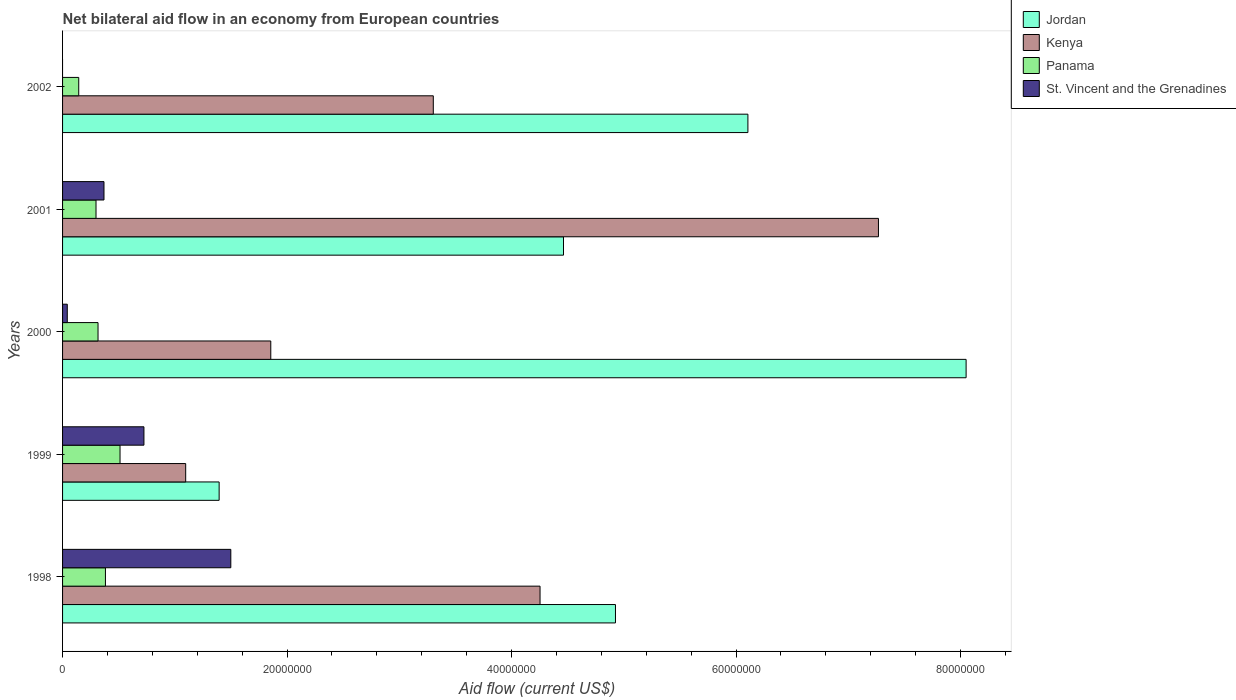How many groups of bars are there?
Provide a short and direct response. 5. How many bars are there on the 2nd tick from the top?
Your response must be concise. 4. How many bars are there on the 3rd tick from the bottom?
Offer a terse response. 4. What is the label of the 4th group of bars from the top?
Provide a short and direct response. 1999. What is the net bilateral aid flow in Jordan in 1999?
Provide a short and direct response. 1.40e+07. Across all years, what is the maximum net bilateral aid flow in St. Vincent and the Grenadines?
Your answer should be very brief. 1.50e+07. Across all years, what is the minimum net bilateral aid flow in St. Vincent and the Grenadines?
Make the answer very short. 0. In which year was the net bilateral aid flow in St. Vincent and the Grenadines maximum?
Make the answer very short. 1998. What is the total net bilateral aid flow in St. Vincent and the Grenadines in the graph?
Provide a succinct answer. 2.64e+07. What is the difference between the net bilateral aid flow in Kenya in 1998 and that in 2001?
Keep it short and to the point. -3.02e+07. What is the difference between the net bilateral aid flow in Panama in 1998 and the net bilateral aid flow in Jordan in 2001?
Offer a very short reply. -4.08e+07. What is the average net bilateral aid flow in Panama per year?
Your response must be concise. 3.30e+06. In the year 2002, what is the difference between the net bilateral aid flow in Jordan and net bilateral aid flow in Panama?
Your answer should be very brief. 5.96e+07. In how many years, is the net bilateral aid flow in Panama greater than 72000000 US$?
Keep it short and to the point. 0. What is the ratio of the net bilateral aid flow in Panama in 2000 to that in 2001?
Provide a short and direct response. 1.06. What is the difference between the highest and the second highest net bilateral aid flow in Jordan?
Your answer should be compact. 1.94e+07. What is the difference between the highest and the lowest net bilateral aid flow in Panama?
Ensure brevity in your answer.  3.68e+06. Are all the bars in the graph horizontal?
Keep it short and to the point. Yes. How many years are there in the graph?
Offer a terse response. 5. Are the values on the major ticks of X-axis written in scientific E-notation?
Provide a short and direct response. No. Does the graph contain any zero values?
Offer a terse response. Yes. Does the graph contain grids?
Keep it short and to the point. No. What is the title of the graph?
Provide a succinct answer. Net bilateral aid flow in an economy from European countries. Does "Mexico" appear as one of the legend labels in the graph?
Provide a succinct answer. No. What is the label or title of the Y-axis?
Provide a short and direct response. Years. What is the Aid flow (current US$) in Jordan in 1998?
Offer a very short reply. 4.93e+07. What is the Aid flow (current US$) of Kenya in 1998?
Offer a terse response. 4.25e+07. What is the Aid flow (current US$) of Panama in 1998?
Make the answer very short. 3.82e+06. What is the Aid flow (current US$) in St. Vincent and the Grenadines in 1998?
Your answer should be compact. 1.50e+07. What is the Aid flow (current US$) of Jordan in 1999?
Give a very brief answer. 1.40e+07. What is the Aid flow (current US$) of Kenya in 1999?
Offer a very short reply. 1.10e+07. What is the Aid flow (current US$) of Panama in 1999?
Your response must be concise. 5.12e+06. What is the Aid flow (current US$) of St. Vincent and the Grenadines in 1999?
Ensure brevity in your answer.  7.25e+06. What is the Aid flow (current US$) of Jordan in 2000?
Ensure brevity in your answer.  8.05e+07. What is the Aid flow (current US$) of Kenya in 2000?
Offer a very short reply. 1.86e+07. What is the Aid flow (current US$) in Panama in 2000?
Give a very brief answer. 3.16e+06. What is the Aid flow (current US$) in St. Vincent and the Grenadines in 2000?
Offer a very short reply. 4.20e+05. What is the Aid flow (current US$) in Jordan in 2001?
Make the answer very short. 4.46e+07. What is the Aid flow (current US$) of Kenya in 2001?
Your answer should be compact. 7.27e+07. What is the Aid flow (current US$) of Panama in 2001?
Your response must be concise. 2.98e+06. What is the Aid flow (current US$) in St. Vincent and the Grenadines in 2001?
Ensure brevity in your answer.  3.69e+06. What is the Aid flow (current US$) of Jordan in 2002?
Provide a short and direct response. 6.11e+07. What is the Aid flow (current US$) of Kenya in 2002?
Your response must be concise. 3.30e+07. What is the Aid flow (current US$) of Panama in 2002?
Your answer should be very brief. 1.44e+06. Across all years, what is the maximum Aid flow (current US$) in Jordan?
Your answer should be compact. 8.05e+07. Across all years, what is the maximum Aid flow (current US$) of Kenya?
Your answer should be compact. 7.27e+07. Across all years, what is the maximum Aid flow (current US$) in Panama?
Make the answer very short. 5.12e+06. Across all years, what is the maximum Aid flow (current US$) of St. Vincent and the Grenadines?
Your answer should be compact. 1.50e+07. Across all years, what is the minimum Aid flow (current US$) of Jordan?
Offer a terse response. 1.40e+07. Across all years, what is the minimum Aid flow (current US$) of Kenya?
Provide a short and direct response. 1.10e+07. Across all years, what is the minimum Aid flow (current US$) of Panama?
Provide a succinct answer. 1.44e+06. What is the total Aid flow (current US$) of Jordan in the graph?
Provide a succinct answer. 2.49e+08. What is the total Aid flow (current US$) in Kenya in the graph?
Give a very brief answer. 1.78e+08. What is the total Aid flow (current US$) of Panama in the graph?
Offer a terse response. 1.65e+07. What is the total Aid flow (current US$) of St. Vincent and the Grenadines in the graph?
Offer a terse response. 2.64e+07. What is the difference between the Aid flow (current US$) in Jordan in 1998 and that in 1999?
Keep it short and to the point. 3.53e+07. What is the difference between the Aid flow (current US$) in Kenya in 1998 and that in 1999?
Your answer should be very brief. 3.16e+07. What is the difference between the Aid flow (current US$) of Panama in 1998 and that in 1999?
Offer a very short reply. -1.30e+06. What is the difference between the Aid flow (current US$) in St. Vincent and the Grenadines in 1998 and that in 1999?
Provide a succinct answer. 7.74e+06. What is the difference between the Aid flow (current US$) in Jordan in 1998 and that in 2000?
Keep it short and to the point. -3.12e+07. What is the difference between the Aid flow (current US$) of Kenya in 1998 and that in 2000?
Ensure brevity in your answer.  2.40e+07. What is the difference between the Aid flow (current US$) in Panama in 1998 and that in 2000?
Make the answer very short. 6.60e+05. What is the difference between the Aid flow (current US$) in St. Vincent and the Grenadines in 1998 and that in 2000?
Offer a very short reply. 1.46e+07. What is the difference between the Aid flow (current US$) in Jordan in 1998 and that in 2001?
Offer a very short reply. 4.63e+06. What is the difference between the Aid flow (current US$) in Kenya in 1998 and that in 2001?
Make the answer very short. -3.02e+07. What is the difference between the Aid flow (current US$) in Panama in 1998 and that in 2001?
Ensure brevity in your answer.  8.40e+05. What is the difference between the Aid flow (current US$) in St. Vincent and the Grenadines in 1998 and that in 2001?
Your response must be concise. 1.13e+07. What is the difference between the Aid flow (current US$) of Jordan in 1998 and that in 2002?
Give a very brief answer. -1.18e+07. What is the difference between the Aid flow (current US$) of Kenya in 1998 and that in 2002?
Ensure brevity in your answer.  9.51e+06. What is the difference between the Aid flow (current US$) in Panama in 1998 and that in 2002?
Your answer should be very brief. 2.38e+06. What is the difference between the Aid flow (current US$) in Jordan in 1999 and that in 2000?
Your answer should be compact. -6.66e+07. What is the difference between the Aid flow (current US$) in Kenya in 1999 and that in 2000?
Provide a short and direct response. -7.58e+06. What is the difference between the Aid flow (current US$) in Panama in 1999 and that in 2000?
Keep it short and to the point. 1.96e+06. What is the difference between the Aid flow (current US$) in St. Vincent and the Grenadines in 1999 and that in 2000?
Your answer should be very brief. 6.83e+06. What is the difference between the Aid flow (current US$) in Jordan in 1999 and that in 2001?
Your answer should be very brief. -3.07e+07. What is the difference between the Aid flow (current US$) of Kenya in 1999 and that in 2001?
Your answer should be compact. -6.17e+07. What is the difference between the Aid flow (current US$) in Panama in 1999 and that in 2001?
Offer a terse response. 2.14e+06. What is the difference between the Aid flow (current US$) in St. Vincent and the Grenadines in 1999 and that in 2001?
Provide a succinct answer. 3.56e+06. What is the difference between the Aid flow (current US$) of Jordan in 1999 and that in 2002?
Offer a very short reply. -4.71e+07. What is the difference between the Aid flow (current US$) of Kenya in 1999 and that in 2002?
Offer a terse response. -2.21e+07. What is the difference between the Aid flow (current US$) of Panama in 1999 and that in 2002?
Your answer should be very brief. 3.68e+06. What is the difference between the Aid flow (current US$) in Jordan in 2000 and that in 2001?
Keep it short and to the point. 3.59e+07. What is the difference between the Aid flow (current US$) of Kenya in 2000 and that in 2001?
Your answer should be very brief. -5.41e+07. What is the difference between the Aid flow (current US$) of Panama in 2000 and that in 2001?
Provide a short and direct response. 1.80e+05. What is the difference between the Aid flow (current US$) in St. Vincent and the Grenadines in 2000 and that in 2001?
Ensure brevity in your answer.  -3.27e+06. What is the difference between the Aid flow (current US$) in Jordan in 2000 and that in 2002?
Offer a terse response. 1.94e+07. What is the difference between the Aid flow (current US$) in Kenya in 2000 and that in 2002?
Keep it short and to the point. -1.45e+07. What is the difference between the Aid flow (current US$) of Panama in 2000 and that in 2002?
Keep it short and to the point. 1.72e+06. What is the difference between the Aid flow (current US$) in Jordan in 2001 and that in 2002?
Your answer should be compact. -1.64e+07. What is the difference between the Aid flow (current US$) in Kenya in 2001 and that in 2002?
Ensure brevity in your answer.  3.97e+07. What is the difference between the Aid flow (current US$) of Panama in 2001 and that in 2002?
Make the answer very short. 1.54e+06. What is the difference between the Aid flow (current US$) in Jordan in 1998 and the Aid flow (current US$) in Kenya in 1999?
Provide a short and direct response. 3.83e+07. What is the difference between the Aid flow (current US$) in Jordan in 1998 and the Aid flow (current US$) in Panama in 1999?
Make the answer very short. 4.41e+07. What is the difference between the Aid flow (current US$) in Jordan in 1998 and the Aid flow (current US$) in St. Vincent and the Grenadines in 1999?
Offer a terse response. 4.20e+07. What is the difference between the Aid flow (current US$) of Kenya in 1998 and the Aid flow (current US$) of Panama in 1999?
Offer a very short reply. 3.74e+07. What is the difference between the Aid flow (current US$) in Kenya in 1998 and the Aid flow (current US$) in St. Vincent and the Grenadines in 1999?
Ensure brevity in your answer.  3.53e+07. What is the difference between the Aid flow (current US$) of Panama in 1998 and the Aid flow (current US$) of St. Vincent and the Grenadines in 1999?
Provide a short and direct response. -3.43e+06. What is the difference between the Aid flow (current US$) in Jordan in 1998 and the Aid flow (current US$) in Kenya in 2000?
Provide a succinct answer. 3.07e+07. What is the difference between the Aid flow (current US$) of Jordan in 1998 and the Aid flow (current US$) of Panama in 2000?
Keep it short and to the point. 4.61e+07. What is the difference between the Aid flow (current US$) in Jordan in 1998 and the Aid flow (current US$) in St. Vincent and the Grenadines in 2000?
Your answer should be compact. 4.88e+07. What is the difference between the Aid flow (current US$) in Kenya in 1998 and the Aid flow (current US$) in Panama in 2000?
Your answer should be compact. 3.94e+07. What is the difference between the Aid flow (current US$) of Kenya in 1998 and the Aid flow (current US$) of St. Vincent and the Grenadines in 2000?
Your answer should be very brief. 4.21e+07. What is the difference between the Aid flow (current US$) of Panama in 1998 and the Aid flow (current US$) of St. Vincent and the Grenadines in 2000?
Offer a very short reply. 3.40e+06. What is the difference between the Aid flow (current US$) of Jordan in 1998 and the Aid flow (current US$) of Kenya in 2001?
Keep it short and to the point. -2.34e+07. What is the difference between the Aid flow (current US$) in Jordan in 1998 and the Aid flow (current US$) in Panama in 2001?
Your answer should be compact. 4.63e+07. What is the difference between the Aid flow (current US$) of Jordan in 1998 and the Aid flow (current US$) of St. Vincent and the Grenadines in 2001?
Give a very brief answer. 4.56e+07. What is the difference between the Aid flow (current US$) in Kenya in 1998 and the Aid flow (current US$) in Panama in 2001?
Give a very brief answer. 3.96e+07. What is the difference between the Aid flow (current US$) in Kenya in 1998 and the Aid flow (current US$) in St. Vincent and the Grenadines in 2001?
Keep it short and to the point. 3.88e+07. What is the difference between the Aid flow (current US$) in Panama in 1998 and the Aid flow (current US$) in St. Vincent and the Grenadines in 2001?
Provide a succinct answer. 1.30e+05. What is the difference between the Aid flow (current US$) in Jordan in 1998 and the Aid flow (current US$) in Kenya in 2002?
Your response must be concise. 1.62e+07. What is the difference between the Aid flow (current US$) in Jordan in 1998 and the Aid flow (current US$) in Panama in 2002?
Your answer should be compact. 4.78e+07. What is the difference between the Aid flow (current US$) of Kenya in 1998 and the Aid flow (current US$) of Panama in 2002?
Make the answer very short. 4.11e+07. What is the difference between the Aid flow (current US$) in Jordan in 1999 and the Aid flow (current US$) in Kenya in 2000?
Keep it short and to the point. -4.60e+06. What is the difference between the Aid flow (current US$) in Jordan in 1999 and the Aid flow (current US$) in Panama in 2000?
Ensure brevity in your answer.  1.08e+07. What is the difference between the Aid flow (current US$) in Jordan in 1999 and the Aid flow (current US$) in St. Vincent and the Grenadines in 2000?
Provide a short and direct response. 1.35e+07. What is the difference between the Aid flow (current US$) of Kenya in 1999 and the Aid flow (current US$) of Panama in 2000?
Make the answer very short. 7.81e+06. What is the difference between the Aid flow (current US$) in Kenya in 1999 and the Aid flow (current US$) in St. Vincent and the Grenadines in 2000?
Your response must be concise. 1.06e+07. What is the difference between the Aid flow (current US$) in Panama in 1999 and the Aid flow (current US$) in St. Vincent and the Grenadines in 2000?
Offer a terse response. 4.70e+06. What is the difference between the Aid flow (current US$) in Jordan in 1999 and the Aid flow (current US$) in Kenya in 2001?
Provide a succinct answer. -5.87e+07. What is the difference between the Aid flow (current US$) of Jordan in 1999 and the Aid flow (current US$) of Panama in 2001?
Give a very brief answer. 1.10e+07. What is the difference between the Aid flow (current US$) of Jordan in 1999 and the Aid flow (current US$) of St. Vincent and the Grenadines in 2001?
Ensure brevity in your answer.  1.03e+07. What is the difference between the Aid flow (current US$) of Kenya in 1999 and the Aid flow (current US$) of Panama in 2001?
Keep it short and to the point. 7.99e+06. What is the difference between the Aid flow (current US$) in Kenya in 1999 and the Aid flow (current US$) in St. Vincent and the Grenadines in 2001?
Provide a short and direct response. 7.28e+06. What is the difference between the Aid flow (current US$) in Panama in 1999 and the Aid flow (current US$) in St. Vincent and the Grenadines in 2001?
Provide a short and direct response. 1.43e+06. What is the difference between the Aid flow (current US$) of Jordan in 1999 and the Aid flow (current US$) of Kenya in 2002?
Offer a terse response. -1.91e+07. What is the difference between the Aid flow (current US$) of Jordan in 1999 and the Aid flow (current US$) of Panama in 2002?
Provide a short and direct response. 1.25e+07. What is the difference between the Aid flow (current US$) in Kenya in 1999 and the Aid flow (current US$) in Panama in 2002?
Offer a terse response. 9.53e+06. What is the difference between the Aid flow (current US$) in Jordan in 2000 and the Aid flow (current US$) in Kenya in 2001?
Provide a short and direct response. 7.81e+06. What is the difference between the Aid flow (current US$) of Jordan in 2000 and the Aid flow (current US$) of Panama in 2001?
Ensure brevity in your answer.  7.75e+07. What is the difference between the Aid flow (current US$) in Jordan in 2000 and the Aid flow (current US$) in St. Vincent and the Grenadines in 2001?
Your answer should be compact. 7.68e+07. What is the difference between the Aid flow (current US$) of Kenya in 2000 and the Aid flow (current US$) of Panama in 2001?
Your response must be concise. 1.56e+07. What is the difference between the Aid flow (current US$) in Kenya in 2000 and the Aid flow (current US$) in St. Vincent and the Grenadines in 2001?
Provide a short and direct response. 1.49e+07. What is the difference between the Aid flow (current US$) of Panama in 2000 and the Aid flow (current US$) of St. Vincent and the Grenadines in 2001?
Your answer should be compact. -5.30e+05. What is the difference between the Aid flow (current US$) of Jordan in 2000 and the Aid flow (current US$) of Kenya in 2002?
Offer a terse response. 4.75e+07. What is the difference between the Aid flow (current US$) of Jordan in 2000 and the Aid flow (current US$) of Panama in 2002?
Offer a very short reply. 7.91e+07. What is the difference between the Aid flow (current US$) of Kenya in 2000 and the Aid flow (current US$) of Panama in 2002?
Offer a very short reply. 1.71e+07. What is the difference between the Aid flow (current US$) in Jordan in 2001 and the Aid flow (current US$) in Kenya in 2002?
Make the answer very short. 1.16e+07. What is the difference between the Aid flow (current US$) of Jordan in 2001 and the Aid flow (current US$) of Panama in 2002?
Offer a terse response. 4.32e+07. What is the difference between the Aid flow (current US$) of Kenya in 2001 and the Aid flow (current US$) of Panama in 2002?
Give a very brief answer. 7.12e+07. What is the average Aid flow (current US$) in Jordan per year?
Ensure brevity in your answer.  4.99e+07. What is the average Aid flow (current US$) in Kenya per year?
Offer a terse response. 3.56e+07. What is the average Aid flow (current US$) in Panama per year?
Your answer should be very brief. 3.30e+06. What is the average Aid flow (current US$) of St. Vincent and the Grenadines per year?
Ensure brevity in your answer.  5.27e+06. In the year 1998, what is the difference between the Aid flow (current US$) of Jordan and Aid flow (current US$) of Kenya?
Provide a short and direct response. 6.72e+06. In the year 1998, what is the difference between the Aid flow (current US$) of Jordan and Aid flow (current US$) of Panama?
Your response must be concise. 4.54e+07. In the year 1998, what is the difference between the Aid flow (current US$) of Jordan and Aid flow (current US$) of St. Vincent and the Grenadines?
Give a very brief answer. 3.43e+07. In the year 1998, what is the difference between the Aid flow (current US$) of Kenya and Aid flow (current US$) of Panama?
Make the answer very short. 3.87e+07. In the year 1998, what is the difference between the Aid flow (current US$) of Kenya and Aid flow (current US$) of St. Vincent and the Grenadines?
Provide a succinct answer. 2.76e+07. In the year 1998, what is the difference between the Aid flow (current US$) in Panama and Aid flow (current US$) in St. Vincent and the Grenadines?
Give a very brief answer. -1.12e+07. In the year 1999, what is the difference between the Aid flow (current US$) in Jordan and Aid flow (current US$) in Kenya?
Offer a terse response. 2.98e+06. In the year 1999, what is the difference between the Aid flow (current US$) in Jordan and Aid flow (current US$) in Panama?
Provide a succinct answer. 8.83e+06. In the year 1999, what is the difference between the Aid flow (current US$) of Jordan and Aid flow (current US$) of St. Vincent and the Grenadines?
Give a very brief answer. 6.70e+06. In the year 1999, what is the difference between the Aid flow (current US$) of Kenya and Aid flow (current US$) of Panama?
Your answer should be very brief. 5.85e+06. In the year 1999, what is the difference between the Aid flow (current US$) in Kenya and Aid flow (current US$) in St. Vincent and the Grenadines?
Offer a very short reply. 3.72e+06. In the year 1999, what is the difference between the Aid flow (current US$) in Panama and Aid flow (current US$) in St. Vincent and the Grenadines?
Your response must be concise. -2.13e+06. In the year 2000, what is the difference between the Aid flow (current US$) in Jordan and Aid flow (current US$) in Kenya?
Keep it short and to the point. 6.20e+07. In the year 2000, what is the difference between the Aid flow (current US$) in Jordan and Aid flow (current US$) in Panama?
Keep it short and to the point. 7.73e+07. In the year 2000, what is the difference between the Aid flow (current US$) of Jordan and Aid flow (current US$) of St. Vincent and the Grenadines?
Your answer should be compact. 8.01e+07. In the year 2000, what is the difference between the Aid flow (current US$) of Kenya and Aid flow (current US$) of Panama?
Your answer should be very brief. 1.54e+07. In the year 2000, what is the difference between the Aid flow (current US$) of Kenya and Aid flow (current US$) of St. Vincent and the Grenadines?
Keep it short and to the point. 1.81e+07. In the year 2000, what is the difference between the Aid flow (current US$) of Panama and Aid flow (current US$) of St. Vincent and the Grenadines?
Offer a very short reply. 2.74e+06. In the year 2001, what is the difference between the Aid flow (current US$) in Jordan and Aid flow (current US$) in Kenya?
Your response must be concise. -2.81e+07. In the year 2001, what is the difference between the Aid flow (current US$) in Jordan and Aid flow (current US$) in Panama?
Provide a succinct answer. 4.16e+07. In the year 2001, what is the difference between the Aid flow (current US$) of Jordan and Aid flow (current US$) of St. Vincent and the Grenadines?
Your answer should be compact. 4.09e+07. In the year 2001, what is the difference between the Aid flow (current US$) in Kenya and Aid flow (current US$) in Panama?
Ensure brevity in your answer.  6.97e+07. In the year 2001, what is the difference between the Aid flow (current US$) of Kenya and Aid flow (current US$) of St. Vincent and the Grenadines?
Keep it short and to the point. 6.90e+07. In the year 2001, what is the difference between the Aid flow (current US$) of Panama and Aid flow (current US$) of St. Vincent and the Grenadines?
Your response must be concise. -7.10e+05. In the year 2002, what is the difference between the Aid flow (current US$) in Jordan and Aid flow (current US$) in Kenya?
Give a very brief answer. 2.80e+07. In the year 2002, what is the difference between the Aid flow (current US$) of Jordan and Aid flow (current US$) of Panama?
Make the answer very short. 5.96e+07. In the year 2002, what is the difference between the Aid flow (current US$) of Kenya and Aid flow (current US$) of Panama?
Keep it short and to the point. 3.16e+07. What is the ratio of the Aid flow (current US$) of Jordan in 1998 to that in 1999?
Keep it short and to the point. 3.53. What is the ratio of the Aid flow (current US$) in Kenya in 1998 to that in 1999?
Give a very brief answer. 3.88. What is the ratio of the Aid flow (current US$) in Panama in 1998 to that in 1999?
Provide a short and direct response. 0.75. What is the ratio of the Aid flow (current US$) in St. Vincent and the Grenadines in 1998 to that in 1999?
Keep it short and to the point. 2.07. What is the ratio of the Aid flow (current US$) in Jordan in 1998 to that in 2000?
Your response must be concise. 0.61. What is the ratio of the Aid flow (current US$) of Kenya in 1998 to that in 2000?
Your answer should be very brief. 2.29. What is the ratio of the Aid flow (current US$) of Panama in 1998 to that in 2000?
Your answer should be very brief. 1.21. What is the ratio of the Aid flow (current US$) in St. Vincent and the Grenadines in 1998 to that in 2000?
Your response must be concise. 35.69. What is the ratio of the Aid flow (current US$) in Jordan in 1998 to that in 2001?
Make the answer very short. 1.1. What is the ratio of the Aid flow (current US$) of Kenya in 1998 to that in 2001?
Offer a very short reply. 0.59. What is the ratio of the Aid flow (current US$) in Panama in 1998 to that in 2001?
Your response must be concise. 1.28. What is the ratio of the Aid flow (current US$) of St. Vincent and the Grenadines in 1998 to that in 2001?
Make the answer very short. 4.06. What is the ratio of the Aid flow (current US$) in Jordan in 1998 to that in 2002?
Your answer should be very brief. 0.81. What is the ratio of the Aid flow (current US$) of Kenya in 1998 to that in 2002?
Ensure brevity in your answer.  1.29. What is the ratio of the Aid flow (current US$) in Panama in 1998 to that in 2002?
Provide a succinct answer. 2.65. What is the ratio of the Aid flow (current US$) of Jordan in 1999 to that in 2000?
Provide a short and direct response. 0.17. What is the ratio of the Aid flow (current US$) in Kenya in 1999 to that in 2000?
Offer a very short reply. 0.59. What is the ratio of the Aid flow (current US$) in Panama in 1999 to that in 2000?
Your answer should be very brief. 1.62. What is the ratio of the Aid flow (current US$) in St. Vincent and the Grenadines in 1999 to that in 2000?
Provide a succinct answer. 17.26. What is the ratio of the Aid flow (current US$) of Jordan in 1999 to that in 2001?
Ensure brevity in your answer.  0.31. What is the ratio of the Aid flow (current US$) in Kenya in 1999 to that in 2001?
Make the answer very short. 0.15. What is the ratio of the Aid flow (current US$) in Panama in 1999 to that in 2001?
Provide a succinct answer. 1.72. What is the ratio of the Aid flow (current US$) in St. Vincent and the Grenadines in 1999 to that in 2001?
Offer a very short reply. 1.96. What is the ratio of the Aid flow (current US$) of Jordan in 1999 to that in 2002?
Offer a very short reply. 0.23. What is the ratio of the Aid flow (current US$) of Kenya in 1999 to that in 2002?
Ensure brevity in your answer.  0.33. What is the ratio of the Aid flow (current US$) of Panama in 1999 to that in 2002?
Provide a succinct answer. 3.56. What is the ratio of the Aid flow (current US$) of Jordan in 2000 to that in 2001?
Offer a very short reply. 1.8. What is the ratio of the Aid flow (current US$) of Kenya in 2000 to that in 2001?
Your answer should be compact. 0.26. What is the ratio of the Aid flow (current US$) in Panama in 2000 to that in 2001?
Offer a very short reply. 1.06. What is the ratio of the Aid flow (current US$) of St. Vincent and the Grenadines in 2000 to that in 2001?
Offer a terse response. 0.11. What is the ratio of the Aid flow (current US$) in Jordan in 2000 to that in 2002?
Your answer should be very brief. 1.32. What is the ratio of the Aid flow (current US$) in Kenya in 2000 to that in 2002?
Provide a succinct answer. 0.56. What is the ratio of the Aid flow (current US$) of Panama in 2000 to that in 2002?
Make the answer very short. 2.19. What is the ratio of the Aid flow (current US$) of Jordan in 2001 to that in 2002?
Make the answer very short. 0.73. What is the ratio of the Aid flow (current US$) of Kenya in 2001 to that in 2002?
Make the answer very short. 2.2. What is the ratio of the Aid flow (current US$) in Panama in 2001 to that in 2002?
Provide a short and direct response. 2.07. What is the difference between the highest and the second highest Aid flow (current US$) in Jordan?
Ensure brevity in your answer.  1.94e+07. What is the difference between the highest and the second highest Aid flow (current US$) of Kenya?
Make the answer very short. 3.02e+07. What is the difference between the highest and the second highest Aid flow (current US$) in Panama?
Your answer should be very brief. 1.30e+06. What is the difference between the highest and the second highest Aid flow (current US$) in St. Vincent and the Grenadines?
Ensure brevity in your answer.  7.74e+06. What is the difference between the highest and the lowest Aid flow (current US$) in Jordan?
Provide a short and direct response. 6.66e+07. What is the difference between the highest and the lowest Aid flow (current US$) of Kenya?
Ensure brevity in your answer.  6.17e+07. What is the difference between the highest and the lowest Aid flow (current US$) of Panama?
Keep it short and to the point. 3.68e+06. What is the difference between the highest and the lowest Aid flow (current US$) in St. Vincent and the Grenadines?
Give a very brief answer. 1.50e+07. 